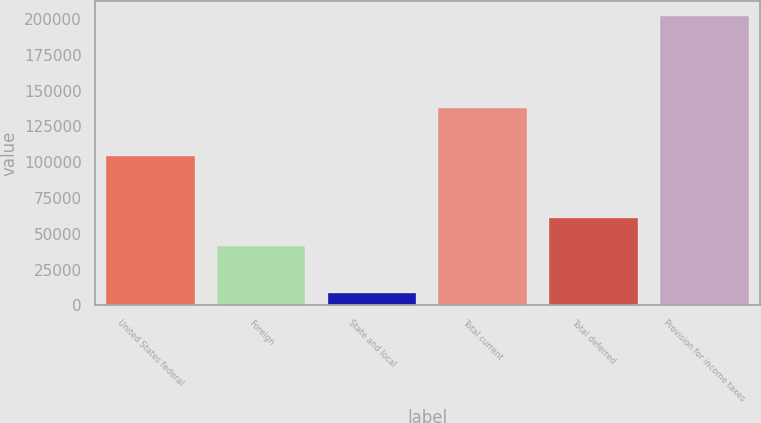<chart> <loc_0><loc_0><loc_500><loc_500><bar_chart><fcel>United States federal<fcel>Foreign<fcel>State and local<fcel>Total current<fcel>Total deferred<fcel>Provision for income taxes<nl><fcel>104587<fcel>41724<fcel>8769<fcel>137542<fcel>61085.4<fcel>202383<nl></chart> 